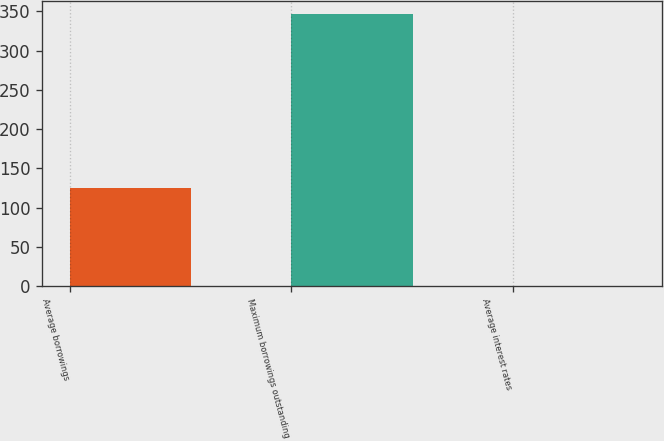<chart> <loc_0><loc_0><loc_500><loc_500><bar_chart><fcel>Average borrowings<fcel>Maximum borrowings outstanding<fcel>Average interest rates<nl><fcel>125<fcel>346<fcel>0.72<nl></chart> 